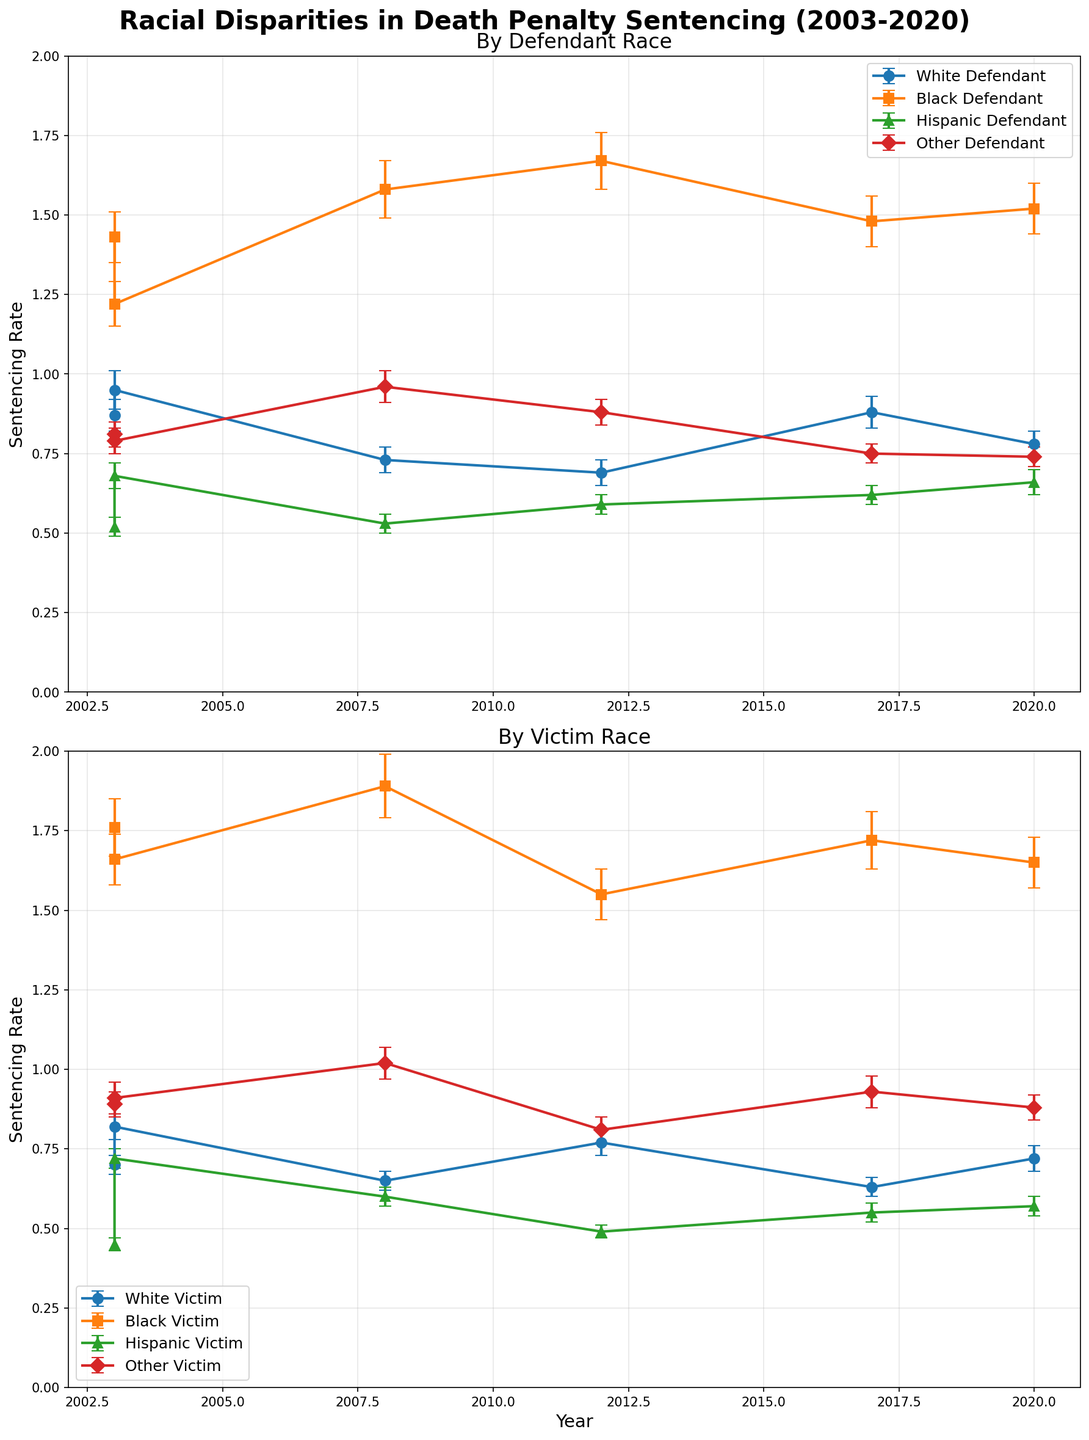What is the title of the figure? The title of the figure is located at the top and is displayed in a large, bold font.
Answer: Racial Disparities in Death Penalty Sentencing (2003-2020) How many subplots are in the figure? The figure is divided into two separate sections or subplots, each covering different aspects.
Answer: 2 What is the trend for Black defendants over the years? By observing the upper subplot labeled "By Defendant Race," the sentencing rate for Black defendants appears consistently higher than for other races across all years.
Answer: Consistently high Which group showed the highest sentencing rate in 2008 for victim race? Looking at the lower subplot labeled "By Victim Race" for the year 2008, the Black Victim group shows the highest sentencing rate with the central line close to the value of 1.89.
Answer: Black Victim Which state has the highest discrepancy between White and Black Defendant sentencing rates in 2003? By comparing the error bars for Texas and Florida in 2003 from the first subplot, Texas shows a higher discrepancy, with Black Defendants having a value of about 1.43 ± 0.08 and White Defendants around 0.87 ± 0.05.
Answer: Texas What was the sentencing rate for Hispanic defendants in Pennsylvania in 2017, and how does it compare to the rate for Other defendants in the same state and year? The subplot for "By Defendant Race" shows the rate for Hispanic Defendants in Pennsylvania in 2017 around 0.62 ± 0.03, while the rate for Other Defendants is around 0.75 ± 0.03. Comparing these values, Other Defendants have a higher rate.
Answer: Hispanic: 0.62 ± 0.03; Other: 0.75 ± 0.03 In which year did the sentencing rate for Hispanic victims peak, and what was the value? In the subplot titled "By Victim Race," the highest rate for Hispanic Victims appears in 2003 in Florida close to the value of 0.72 ± 0.03.
Answer: 2003, 0.72 ± 0.03 By observing both subplots, which racial disparity remains most consistent regardless of the year? When comparing both subplots, the sentencing rate for Black individuals, whether as defendants or victims, remains consistently higher than for other races across all years.
Answer: Black How does the range for White Victim sentencing rates in 2003 compare to 2017? In the lower subplot "By Victim Race," the rate in 2003 (Texas) is about 0.7 ± 0.03, whereas in 2017 (Pennsylvania) it is approximately 0.63 ± 0.03, indicating a slight decrease.
Answer: Slight decrease Which year in California saw the highest average sentencing rate when considering all four racial groups of defendants? For California in 2008 in the upper subplot, we need to average the values: (0.73 + 1.58 + 0.53 + 0.96) / 4 = (3.8/4) = 0.95. No other year in the same state shows a higher value.
Answer: 2008 (average 0.95) Is there any year where the sentencing rate for White Victims surpassed that of Black Victims? From the lower subplot, in none of the years does the rate for White Victims surpass the rate for Black Victims. Black Victims consistently have higher or equal sentencing rates.
Answer: No 